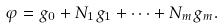Convert formula to latex. <formula><loc_0><loc_0><loc_500><loc_500>\varphi = g _ { 0 } + N _ { 1 } g _ { 1 } + \dots + N _ { m } g _ { m } .</formula> 